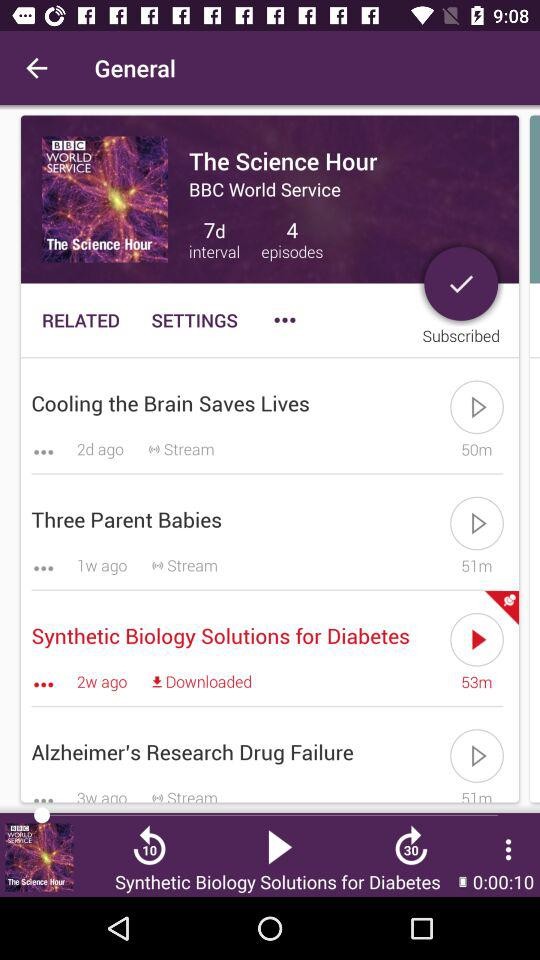What is the channel name? The channel name is "BBC World Service". 